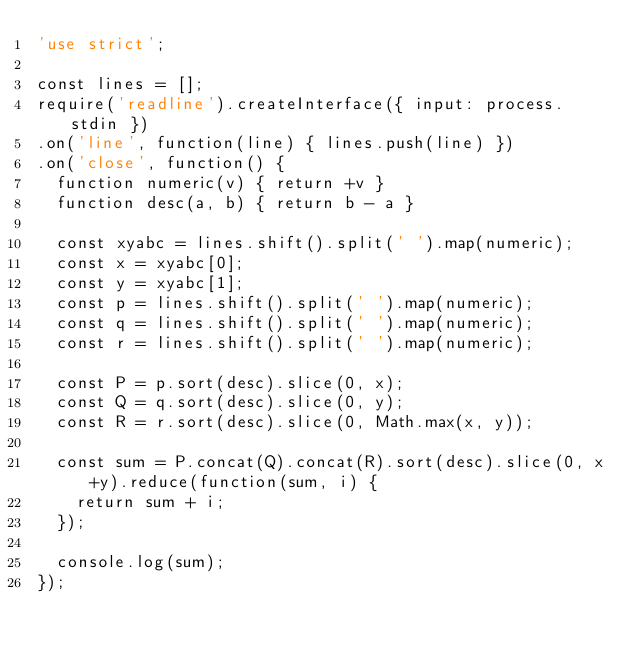<code> <loc_0><loc_0><loc_500><loc_500><_JavaScript_>'use strict';

const lines = [];
require('readline').createInterface({ input: process.stdin })
.on('line', function(line) { lines.push(line) })
.on('close', function() {
  function numeric(v) { return +v }
  function desc(a, b) { return b - a }
  
  const xyabc = lines.shift().split(' ').map(numeric);
  const x = xyabc[0];
  const y = xyabc[1];
  const p = lines.shift().split(' ').map(numeric);
  const q = lines.shift().split(' ').map(numeric);
  const r = lines.shift().split(' ').map(numeric);
  
  const P = p.sort(desc).slice(0, x);
  const Q = q.sort(desc).slice(0, y);
  const R = r.sort(desc).slice(0, Math.max(x, y));
  
  const sum = P.concat(Q).concat(R).sort(desc).slice(0, x+y).reduce(function(sum, i) {
    return sum + i;
  });

  console.log(sum);
});
</code> 